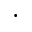<formula> <loc_0><loc_0><loc_500><loc_500>\cdot</formula> 